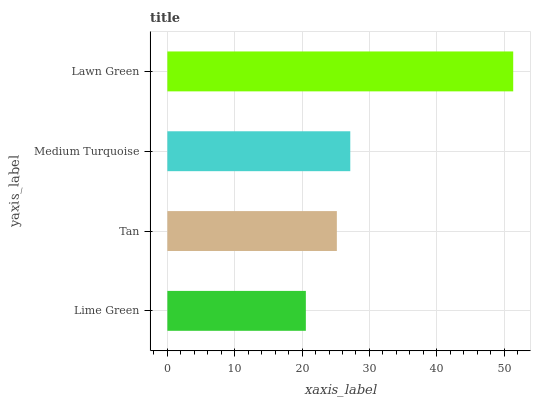Is Lime Green the minimum?
Answer yes or no. Yes. Is Lawn Green the maximum?
Answer yes or no. Yes. Is Tan the minimum?
Answer yes or no. No. Is Tan the maximum?
Answer yes or no. No. Is Tan greater than Lime Green?
Answer yes or no. Yes. Is Lime Green less than Tan?
Answer yes or no. Yes. Is Lime Green greater than Tan?
Answer yes or no. No. Is Tan less than Lime Green?
Answer yes or no. No. Is Medium Turquoise the high median?
Answer yes or no. Yes. Is Tan the low median?
Answer yes or no. Yes. Is Lime Green the high median?
Answer yes or no. No. Is Lawn Green the low median?
Answer yes or no. No. 